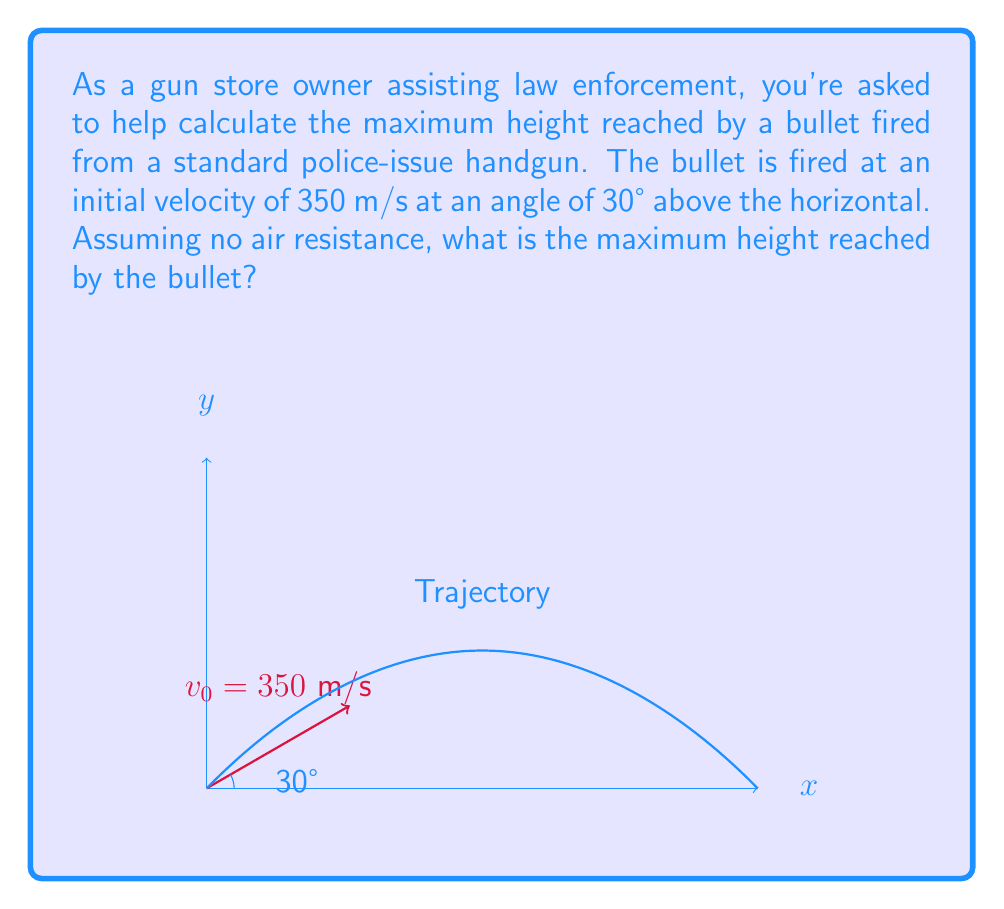Teach me how to tackle this problem. To solve this problem, we'll use the equations of motion for projectile motion. The maximum height is reached when the vertical component of velocity becomes zero.

1) First, we need to find the vertical component of the initial velocity:
   $v_{0y} = v_0 \sin \theta = 350 \sin 30° = 175$ m/s

2) The time to reach the maximum height is when $v_y = 0$:
   $v_y = v_{0y} - gt = 0$
   $t = \frac{v_{0y}}{g} = \frac{175}{9.8} \approx 17.86$ seconds

3) Now we can use the equation for displacement to find the maximum height:
   $y = v_{0y}t - \frac{1}{2}gt^2$

4) Substituting the values:
   $y_{max} = 175 \cdot 17.86 - \frac{1}{2} \cdot 9.8 \cdot 17.86^2$
   $y_{max} = 3125.5 - 1562.75 = 1562.75$ meters

Therefore, the maximum height reached by the bullet is approximately 1562.75 meters.
Answer: 1562.75 meters 